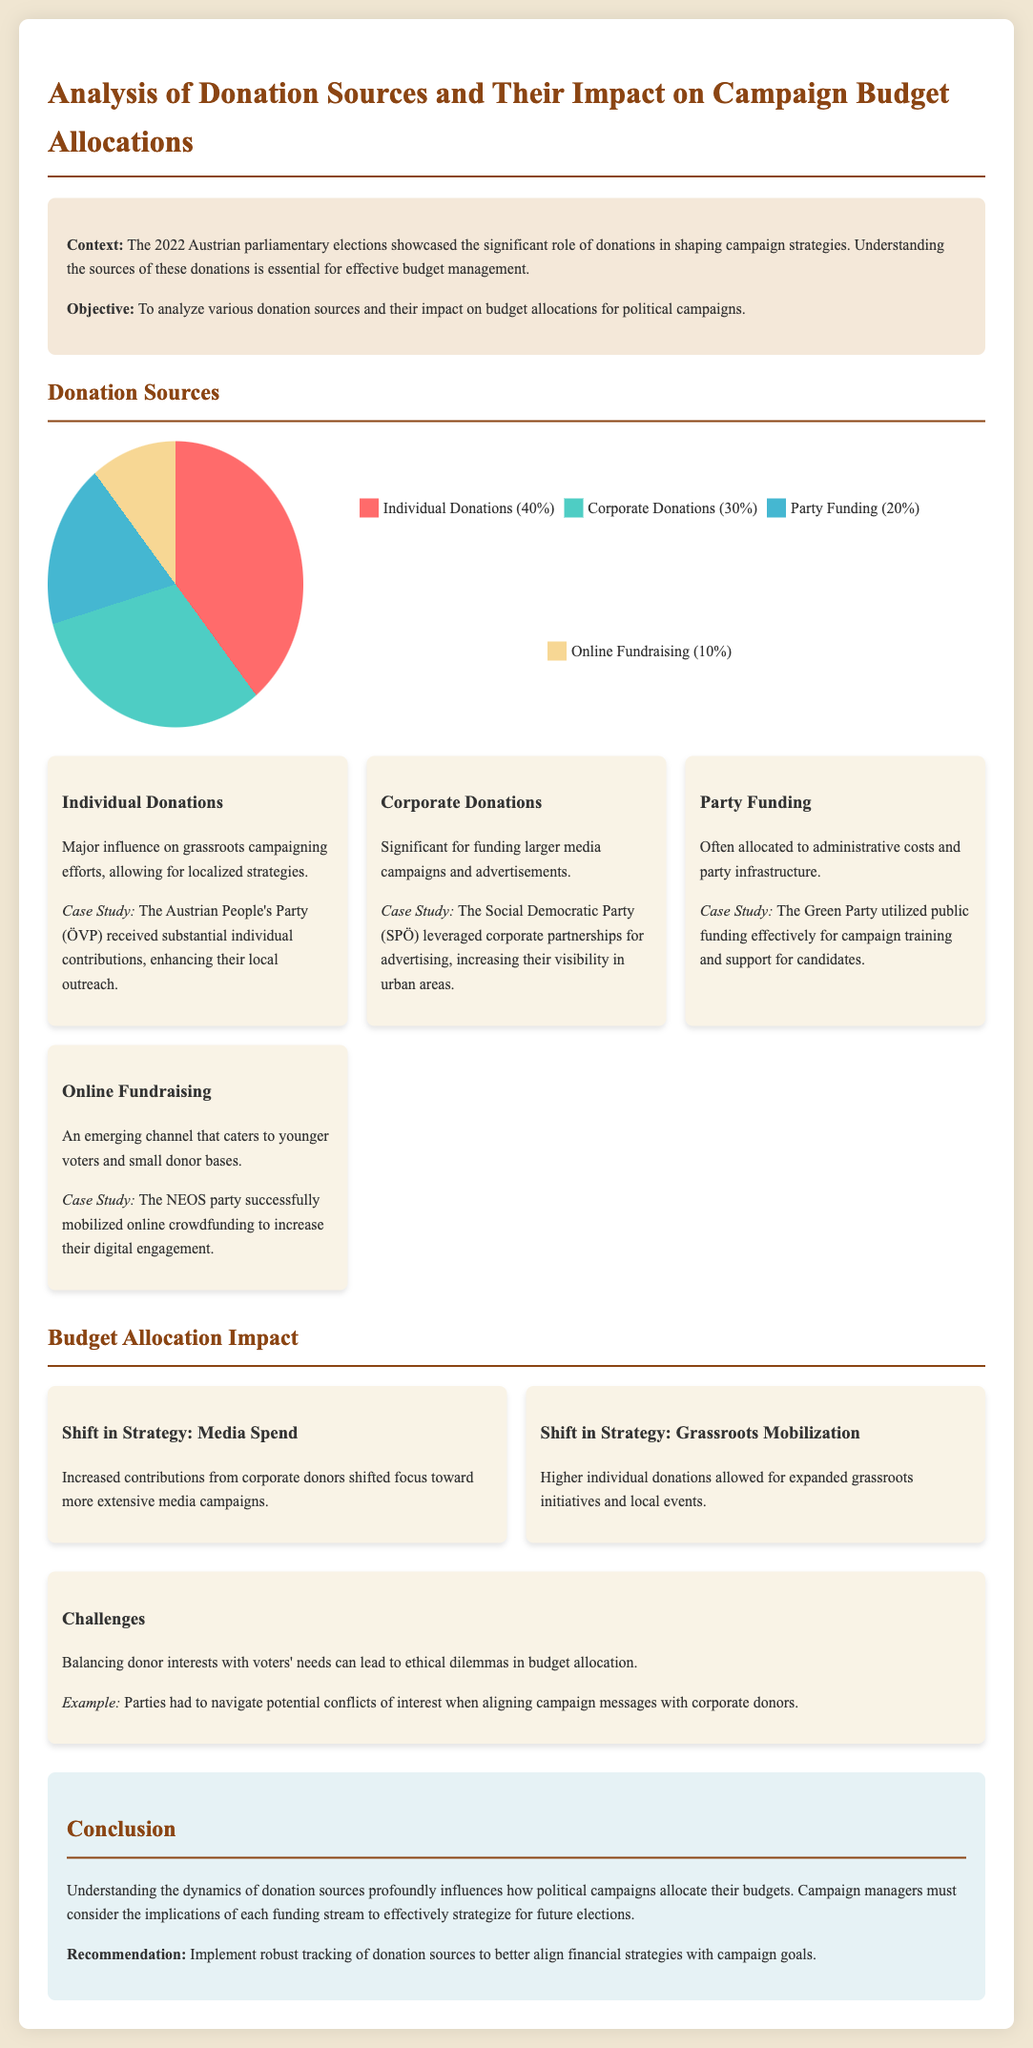What is the percentage of individual donations? The document states that individual donations account for 40% of the total donations.
Answer: 40% What is the primary impact of corporate donations? Corporate donations are significant for funding larger media campaigns and advertisements.
Answer: Media campaigns Which party received substantial individual contributions? The Austrian People's Party (ÖVP) is highlighted as receiving substantial individual contributions enhancing their outreach.
Answer: Austrian People's Party (ÖVP) What funding source is most utilized for administrative costs? Party Funding is often allocated to administrative costs and party infrastructure.
Answer: Party Funding What was a major strategy shift due to increased corporate contributions? The increase in corporate donations led to a focus toward more extensive media campaigns.
Answer: Media campaigns Which party effectively used public funding for candidate support? The Green Party utilized public funding effectively for campaign training and support for candidates.
Answer: Green Party What percentage of donations came from online fundraising? Online fundraising accounts for 10% of the total donations.
Answer: 10% What was a key challenge noted regarding donor interests? The document mentions ethical dilemmas in balancing donor interests with voters' needs.
Answer: Ethical dilemmas What does the conclusion recommend for future campaign strategies? The conclusion recommends implementing robust tracking of donation sources.
Answer: Robust tracking 